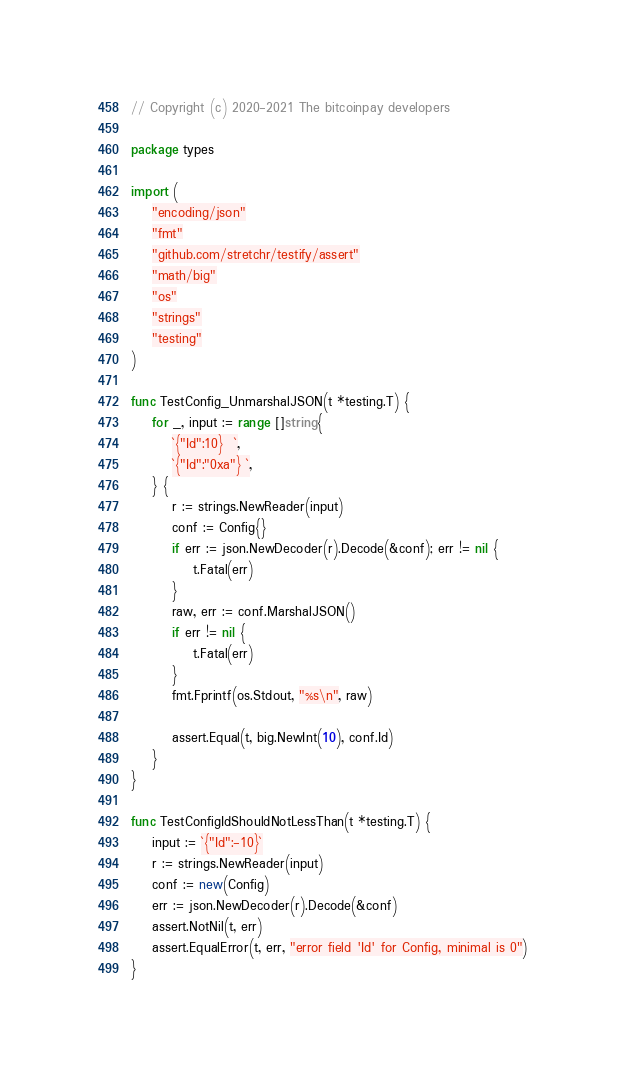<code> <loc_0><loc_0><loc_500><loc_500><_Go_>// Copyright (c) 2020-2021 The bitcoinpay developers

package types

import (
	"encoding/json"
	"fmt"
	"github.com/stretchr/testify/assert"
	"math/big"
	"os"
	"strings"
	"testing"
)

func TestConfig_UnmarshalJSON(t *testing.T) {
	for _, input := range []string{
		`{"Id":10}  `,
		`{"Id":"0xa"} `,
	} {
		r := strings.NewReader(input)
		conf := Config{}
		if err := json.NewDecoder(r).Decode(&conf); err != nil {
			t.Fatal(err)
		}
		raw, err := conf.MarshalJSON()
		if err != nil {
			t.Fatal(err)
		}
		fmt.Fprintf(os.Stdout, "%s\n", raw)

		assert.Equal(t, big.NewInt(10), conf.Id)
	}
}

func TestConfigIdShouldNotLessThan(t *testing.T) {
	input := `{"Id":-10}`
	r := strings.NewReader(input)
	conf := new(Config)
	err := json.NewDecoder(r).Decode(&conf)
	assert.NotNil(t, err)
	assert.EqualError(t, err, "error field 'Id' for Config, minimal is 0")
}
</code> 